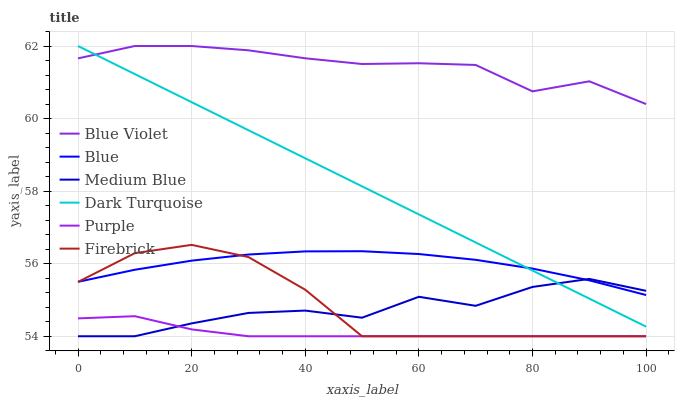Does Purple have the minimum area under the curve?
Answer yes or no. Yes. Does Blue Violet have the maximum area under the curve?
Answer yes or no. Yes. Does Dark Turquoise have the minimum area under the curve?
Answer yes or no. No. Does Dark Turquoise have the maximum area under the curve?
Answer yes or no. No. Is Dark Turquoise the smoothest?
Answer yes or no. Yes. Is Medium Blue the roughest?
Answer yes or no. Yes. Is Purple the smoothest?
Answer yes or no. No. Is Purple the roughest?
Answer yes or no. No. Does Purple have the lowest value?
Answer yes or no. Yes. Does Dark Turquoise have the lowest value?
Answer yes or no. No. Does Blue Violet have the highest value?
Answer yes or no. Yes. Does Purple have the highest value?
Answer yes or no. No. Is Blue less than Blue Violet?
Answer yes or no. Yes. Is Blue Violet greater than Purple?
Answer yes or no. Yes. Does Dark Turquoise intersect Blue Violet?
Answer yes or no. Yes. Is Dark Turquoise less than Blue Violet?
Answer yes or no. No. Is Dark Turquoise greater than Blue Violet?
Answer yes or no. No. Does Blue intersect Blue Violet?
Answer yes or no. No. 